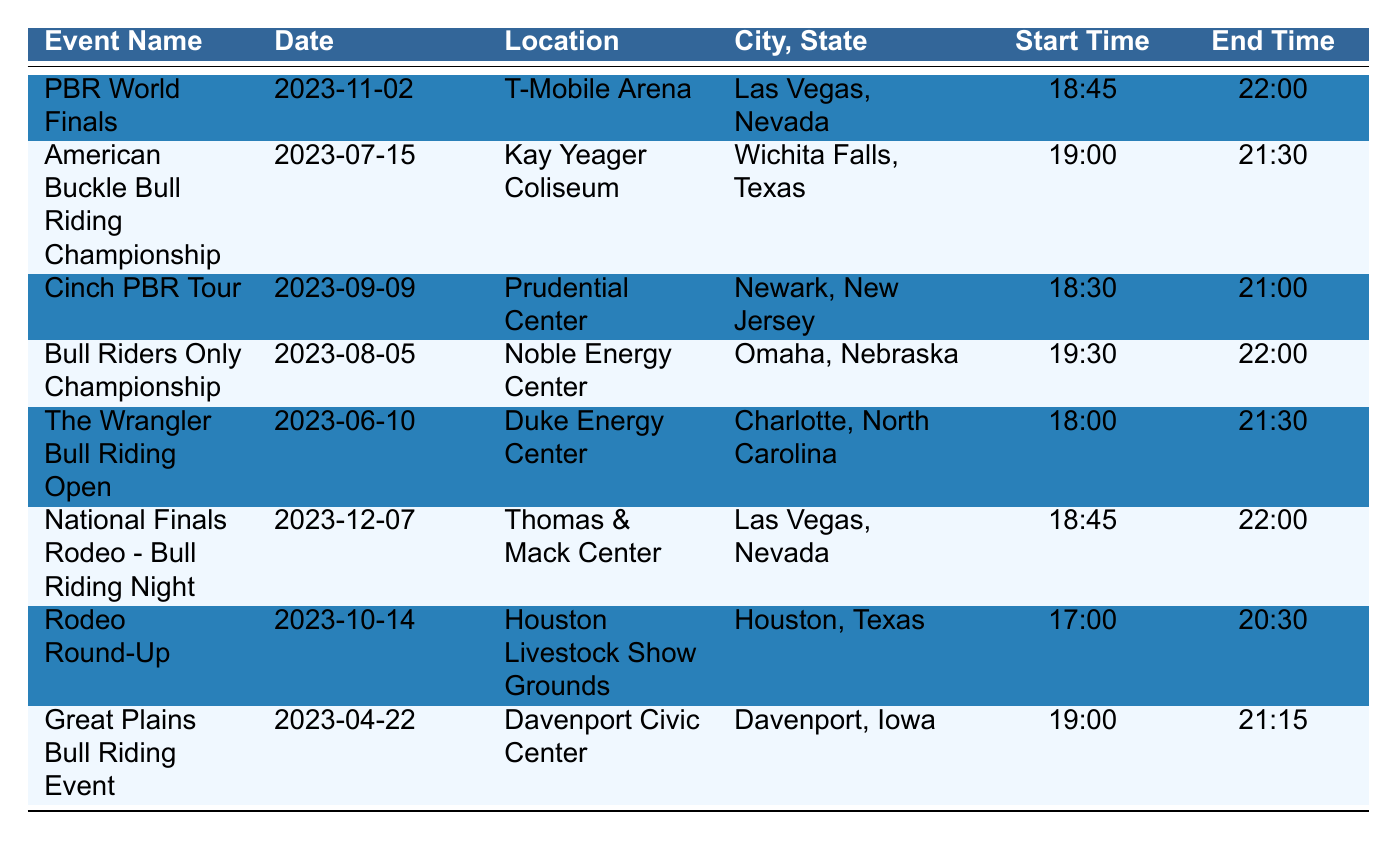What is the date of the PBR World Finals? The table lists the event name along with its corresponding date. For the "PBR World Finals," the date noted is "2023-11-02."
Answer: 2023-11-02 Which city hosts the American Buckle Bull Riding Championship? By locating the row for "American Buckle Bull Riding Championship," you see that it is held in "Wichita Falls, Texas."
Answer: Wichita Falls How many events are scheduled in November 2023? From the table, we can observe that there is only one event in November, which is the "PBR World Finals" on "2023-11-02."
Answer: 1 What is the average start time of all the events listed? The start times are: 18:45, 19:00, 18:30, 19:30, 18:00, 18:45, 17:00, and 19:00. Converting these to minutes after midnight gives us: 1125, 1140, 1110, 1170, 1080, 1125, 1020, and 1140. The average is (1125 + 1140 + 1110 + 1170 + 1080 + 1125 + 1020 + 1140) / 8 = 1114 minutes, which is 18:34 when converted back to hours and minutes.
Answer: 18:34 Is the location for the Great Plains Bull Riding Event in a state that has hosted any other event? The Great Plains Bull Riding Event is in "Davenport, Iowa." Checking the table indicates there are no other events in Iowa, so the answer is no.
Answer: No 